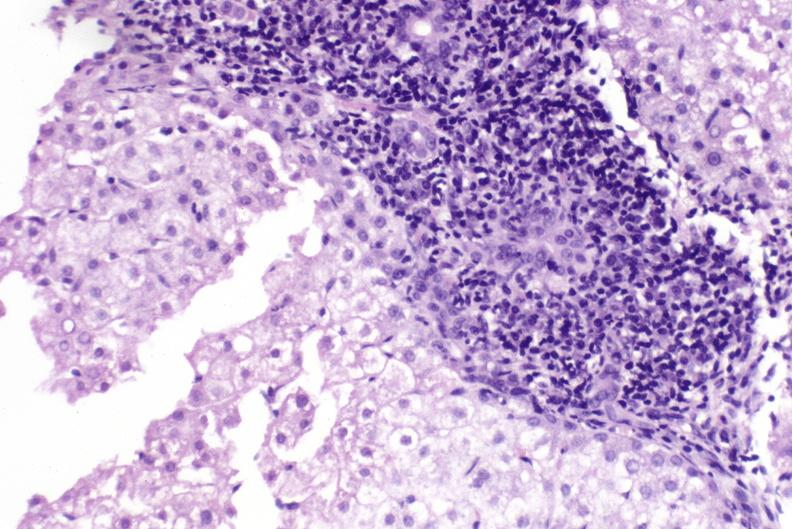does this image show primary biliary cirrhosis?
Answer the question using a single word or phrase. Yes 